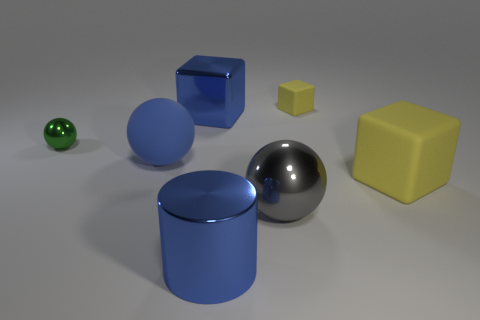Add 3 small blue shiny blocks. How many objects exist? 10 Subtract all spheres. How many objects are left? 4 Subtract all large blue objects. Subtract all yellow objects. How many objects are left? 2 Add 4 large blue cylinders. How many large blue cylinders are left? 5 Add 1 green matte cylinders. How many green matte cylinders exist? 1 Subtract 1 green spheres. How many objects are left? 6 